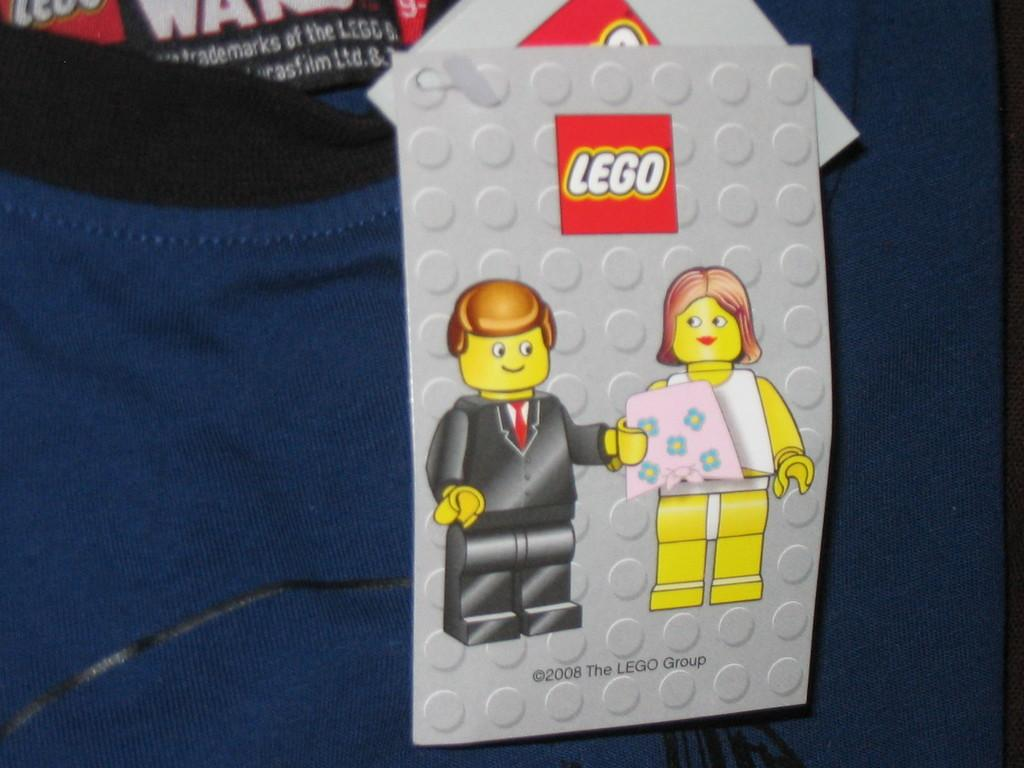Provide a one-sentence caption for the provided image. A blue shirt with a black collar containing an attached tag that says Lego on top and 2008 The Lego Group on the bottom. 